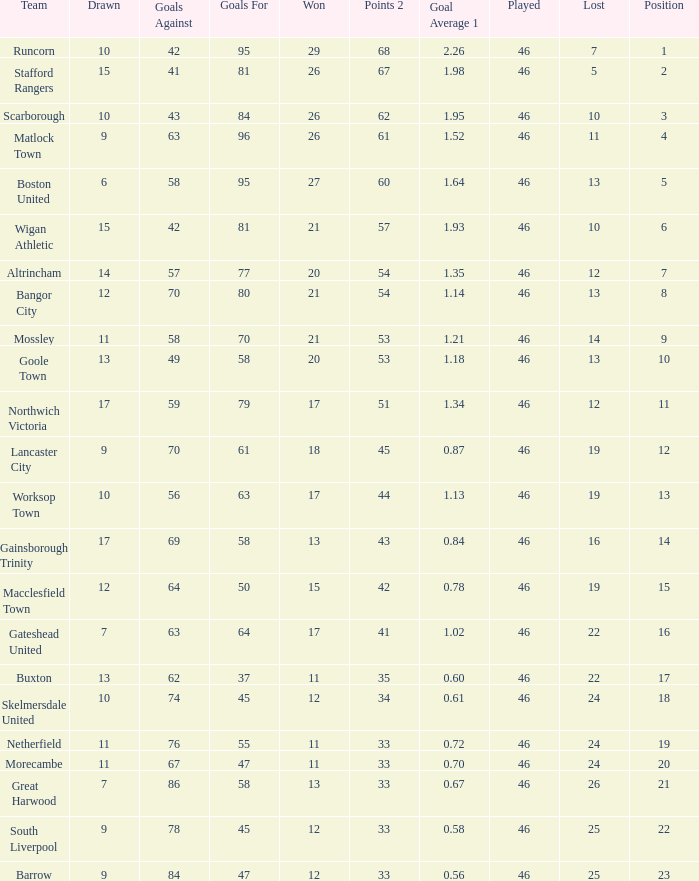Which team had goal averages of 1.34? Northwich Victoria. Help me parse the entirety of this table. {'header': ['Team', 'Drawn', 'Goals Against', 'Goals For', 'Won', 'Points 2', 'Goal Average 1', 'Played', 'Lost', 'Position'], 'rows': [['Runcorn', '10', '42', '95', '29', '68', '2.26', '46', '7', '1'], ['Stafford Rangers', '15', '41', '81', '26', '67', '1.98', '46', '5', '2'], ['Scarborough', '10', '43', '84', '26', '62', '1.95', '46', '10', '3'], ['Matlock Town', '9', '63', '96', '26', '61', '1.52', '46', '11', '4'], ['Boston United', '6', '58', '95', '27', '60', '1.64', '46', '13', '5'], ['Wigan Athletic', '15', '42', '81', '21', '57', '1.93', '46', '10', '6'], ['Altrincham', '14', '57', '77', '20', '54', '1.35', '46', '12', '7'], ['Bangor City', '12', '70', '80', '21', '54', '1.14', '46', '13', '8'], ['Mossley', '11', '58', '70', '21', '53', '1.21', '46', '14', '9'], ['Goole Town', '13', '49', '58', '20', '53', '1.18', '46', '13', '10'], ['Northwich Victoria', '17', '59', '79', '17', '51', '1.34', '46', '12', '11'], ['Lancaster City', '9', '70', '61', '18', '45', '0.87', '46', '19', '12'], ['Worksop Town', '10', '56', '63', '17', '44', '1.13', '46', '19', '13'], ['Gainsborough Trinity', '17', '69', '58', '13', '43', '0.84', '46', '16', '14'], ['Macclesfield Town', '12', '64', '50', '15', '42', '0.78', '46', '19', '15'], ['Gateshead United', '7', '63', '64', '17', '41', '1.02', '46', '22', '16'], ['Buxton', '13', '62', '37', '11', '35', '0.60', '46', '22', '17'], ['Skelmersdale United', '10', '74', '45', '12', '34', '0.61', '46', '24', '18'], ['Netherfield', '11', '76', '55', '11', '33', '0.72', '46', '24', '19'], ['Morecambe', '11', '67', '47', '11', '33', '0.70', '46', '24', '20'], ['Great Harwood', '7', '86', '58', '13', '33', '0.67', '46', '26', '21'], ['South Liverpool', '9', '78', '45', '12', '33', '0.58', '46', '25', '22'], ['Barrow', '9', '84', '47', '12', '33', '0.56', '46', '25', '23']]} 